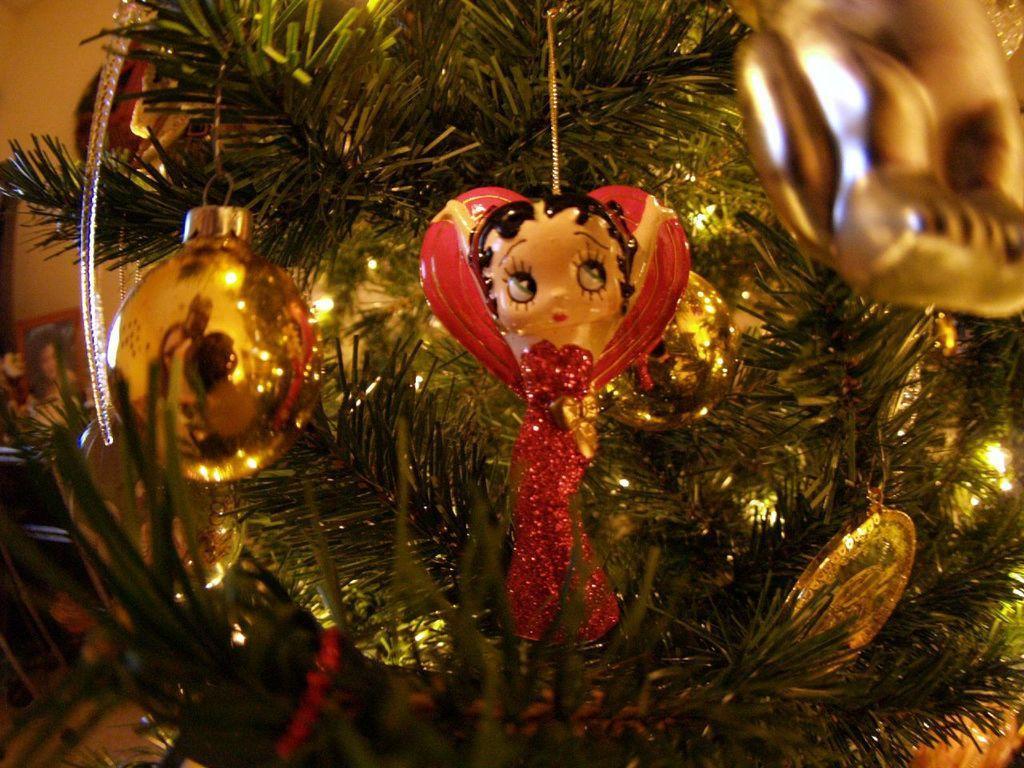How would you summarize this image in a sentence or two? In this picture there is a decorated Christmas tree in the center of the image with Christmas ornaments. 